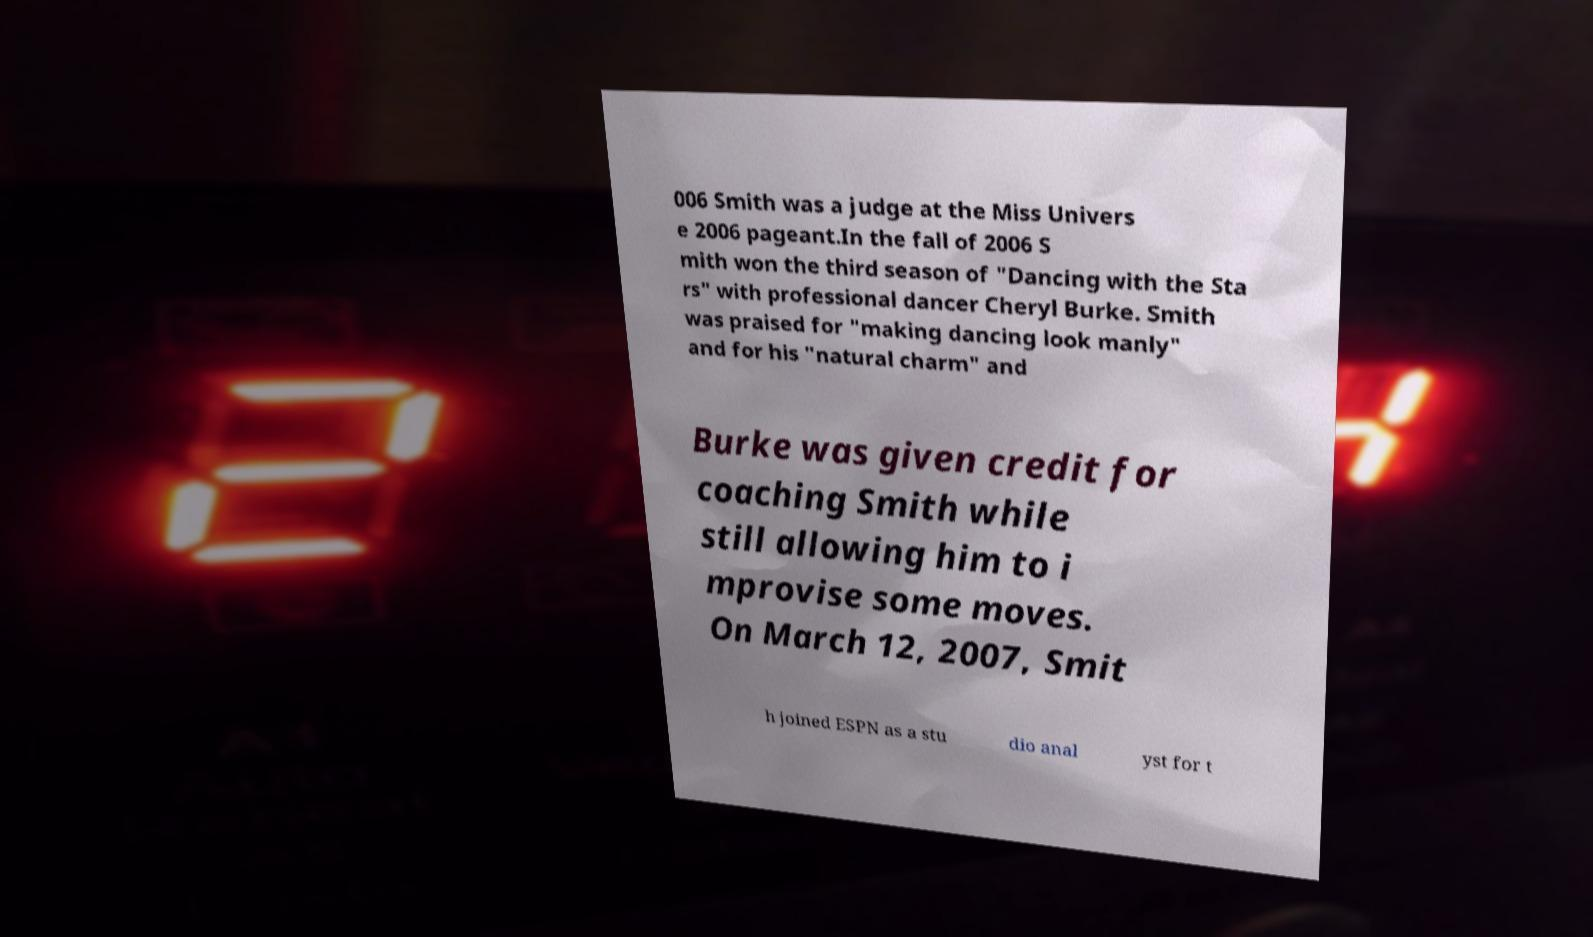There's text embedded in this image that I need extracted. Can you transcribe it verbatim? 006 Smith was a judge at the Miss Univers e 2006 pageant.In the fall of 2006 S mith won the third season of "Dancing with the Sta rs" with professional dancer Cheryl Burke. Smith was praised for "making dancing look manly" and for his "natural charm" and Burke was given credit for coaching Smith while still allowing him to i mprovise some moves. On March 12, 2007, Smit h joined ESPN as a stu dio anal yst for t 